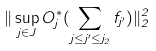<formula> <loc_0><loc_0><loc_500><loc_500>\| \sup _ { j \in J } O _ { j } ^ { * } ( \sum _ { j \leq j ^ { \prime } \leq j _ { 2 } } f _ { j ^ { \prime } } ) \| _ { 2 } ^ { 2 }</formula> 